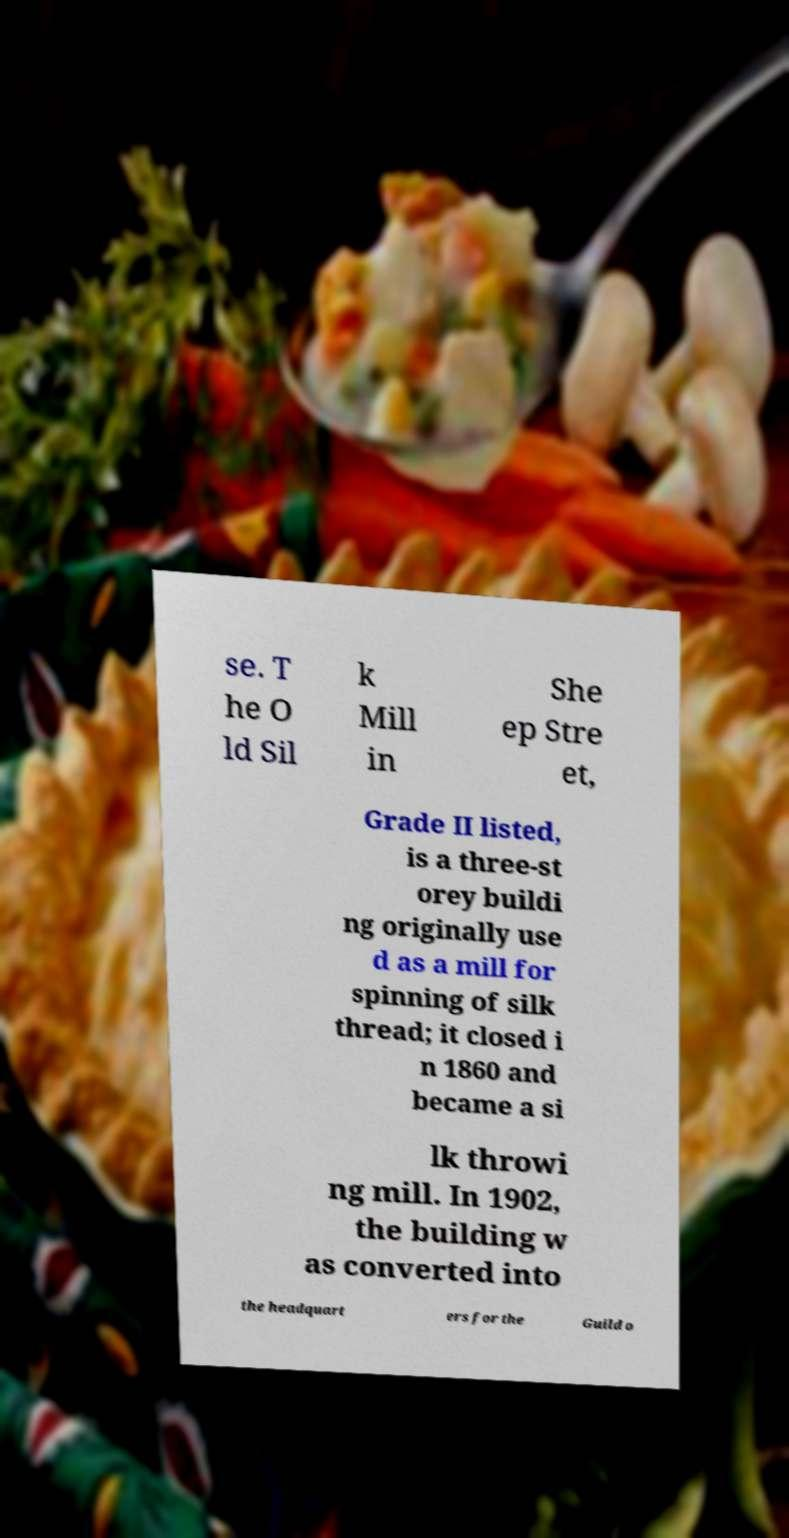What messages or text are displayed in this image? I need them in a readable, typed format. se. T he O ld Sil k Mill in She ep Stre et, Grade II listed, is a three-st orey buildi ng originally use d as a mill for spinning of silk thread; it closed i n 1860 and became a si lk throwi ng mill. In 1902, the building w as converted into the headquart ers for the Guild o 